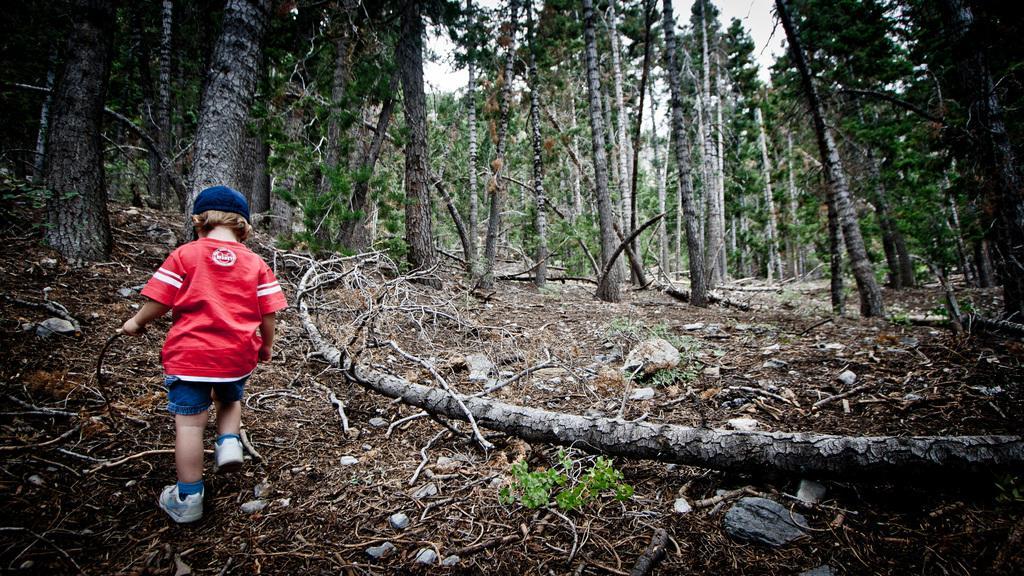Can you describe this image briefly? In this image we can see a child walking on the ground and holding a stick. And there are trees and sky in the background. 